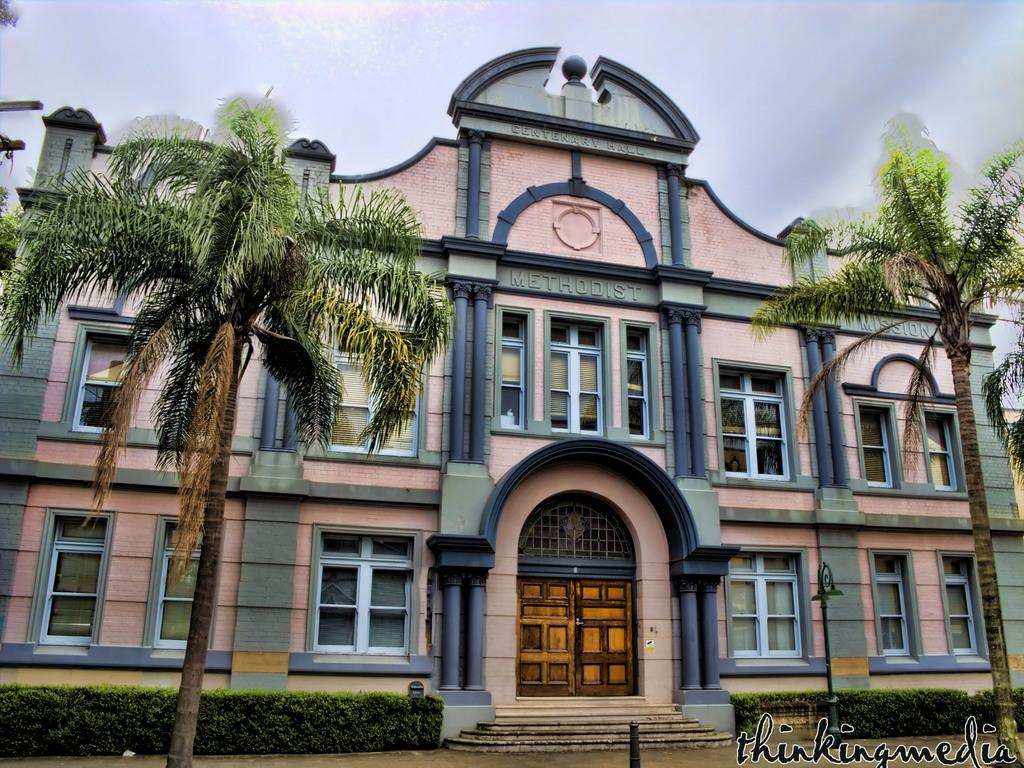What type of natural elements can be seen in the image? There are trees and plants in the image. What type of man-made structure is present in the image? There is a building in the image. What features can be observed on the building? The building has windows and a door. What is visible in the background of the image? The sky is visible in the background of the image. What is present in the bottom right corner of the image? There is text in the bottom right corner of the image. How many children are shown taking care of their mouths in the image? There are no children or mouths present in the image. What type of care is being provided to the plants in the image? The image does not show any care being provided to the plants; it only shows their presence. 